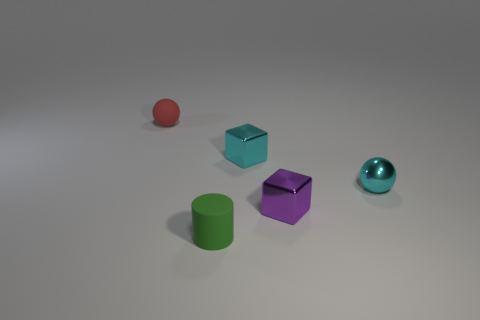What is the size of the block that is the same color as the tiny shiny ball?
Keep it short and to the point. Small. There is a green cylinder that is the same material as the red ball; what size is it?
Offer a terse response. Small. Are there fewer small matte objects than tiny cyan spheres?
Give a very brief answer. No. There is a red object that is the same size as the cyan ball; what is it made of?
Provide a short and direct response. Rubber. Are there more cyan cubes than large gray metal cylinders?
Provide a short and direct response. Yes. What number of other things are the same color as the metallic sphere?
Ensure brevity in your answer.  1. How many things are on the right side of the cylinder and left of the cyan sphere?
Make the answer very short. 2. Is there any other thing that is the same size as the green matte object?
Provide a short and direct response. Yes. Is the number of cyan balls behind the tiny metal sphere greater than the number of rubber things behind the cylinder?
Provide a succinct answer. No. There is a tiny sphere that is on the right side of the small green object; what is its material?
Give a very brief answer. Metal. 